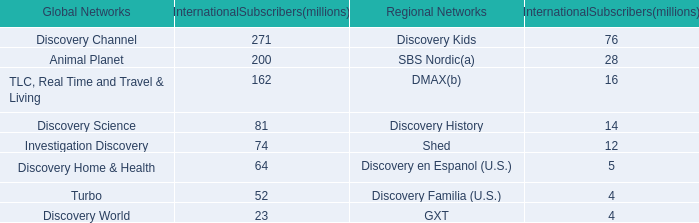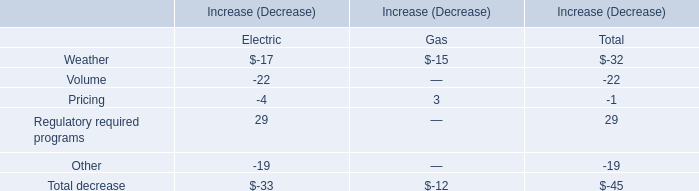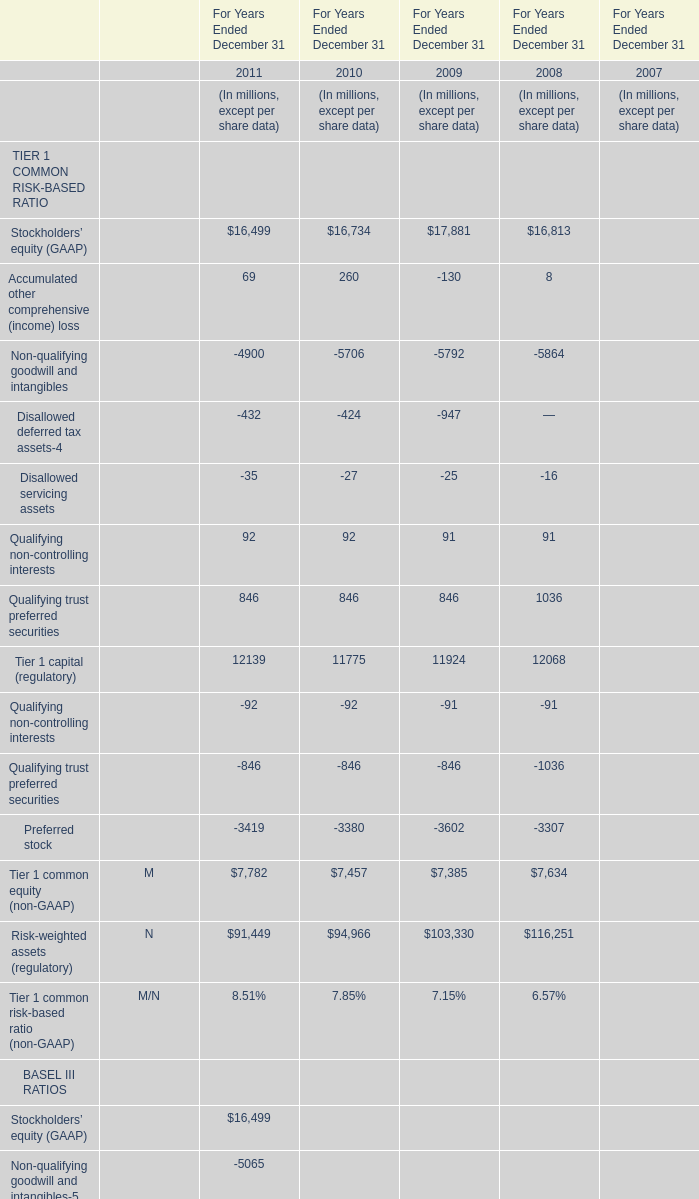In the year with largest amount of Qualifying non-controlling interests, what's the increasing rate of Qualifying non-controlling interests? 
Computations: ((92 - 91) / 92)
Answer: 0.01087. 